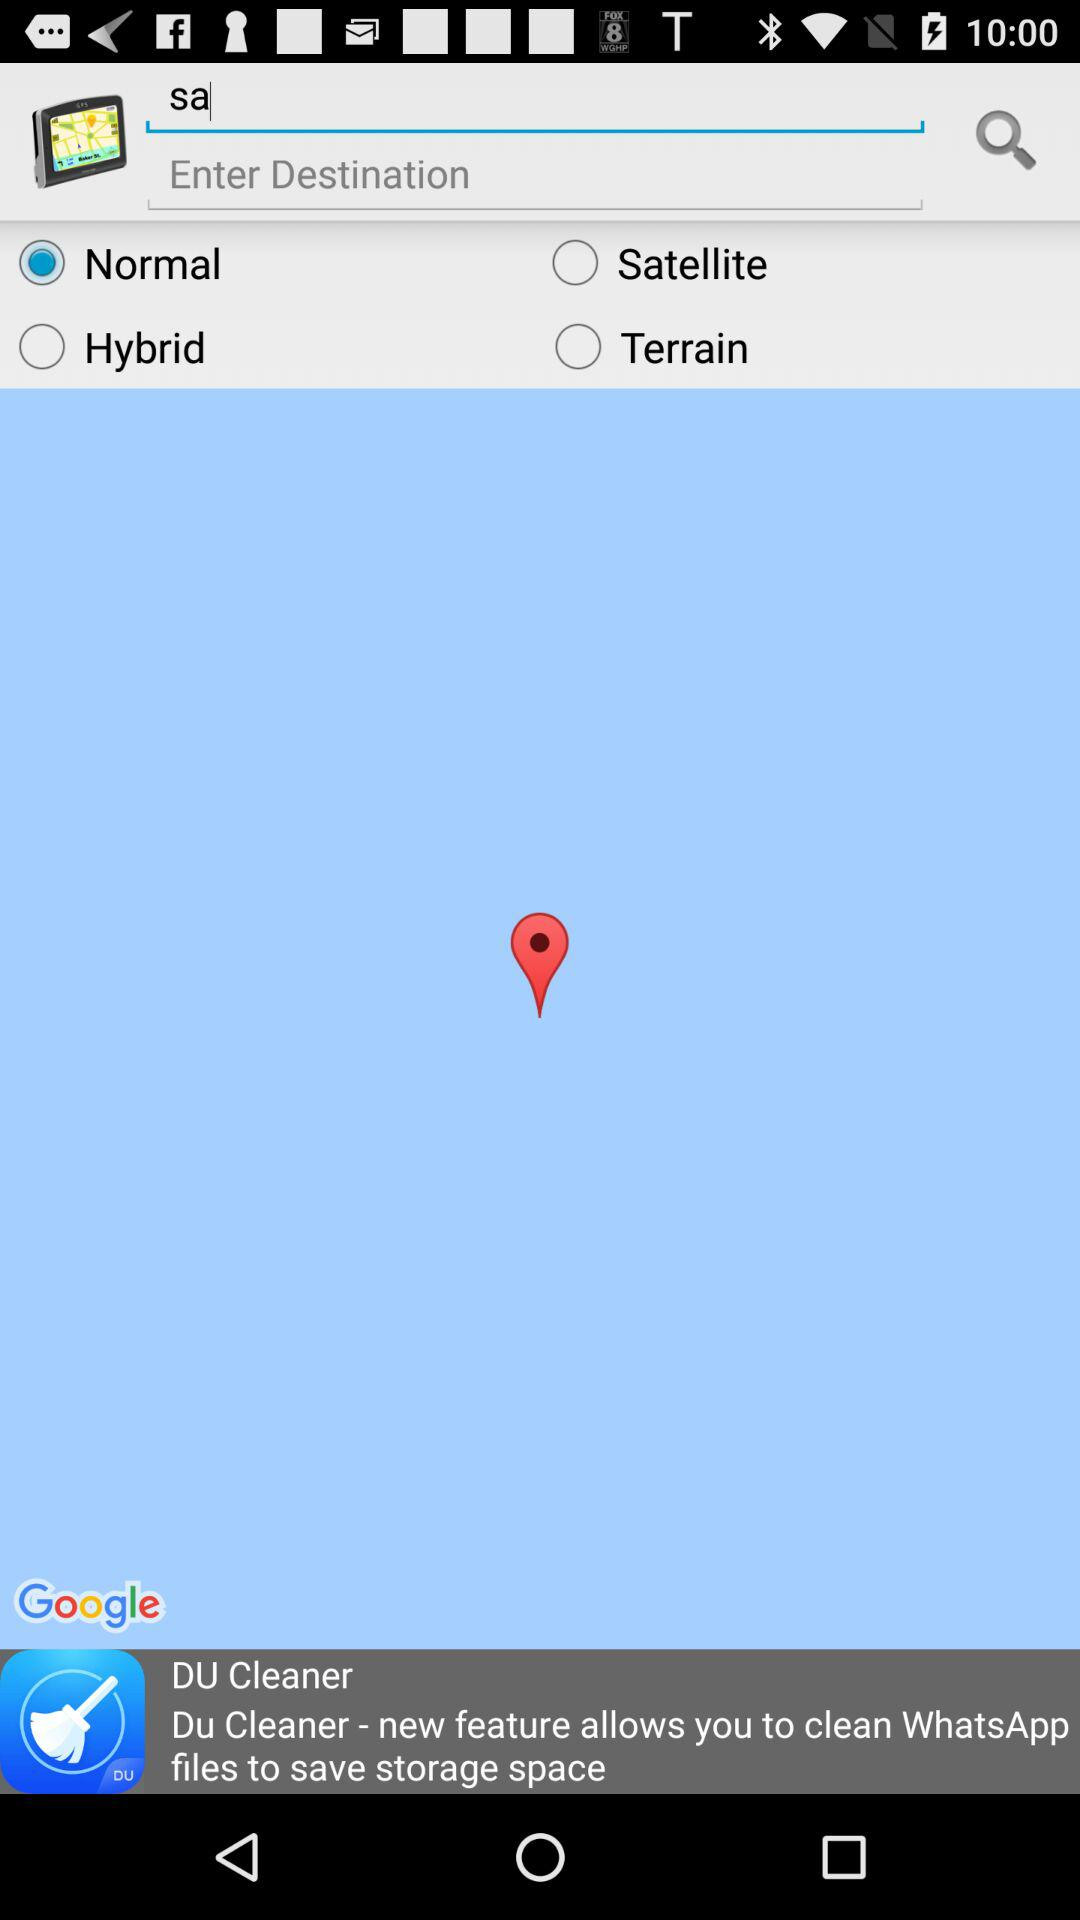Which option is selected? The selected option is "Normal". 